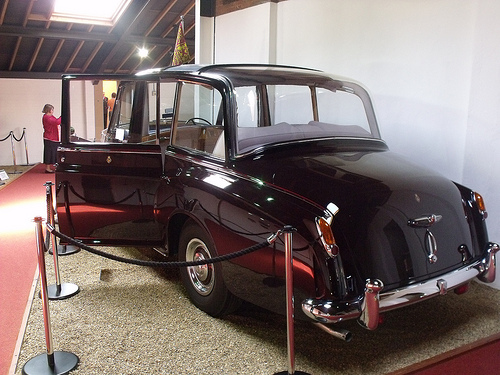<image>
Is the car next to the rope? Yes. The car is positioned adjacent to the rope, located nearby in the same general area. 